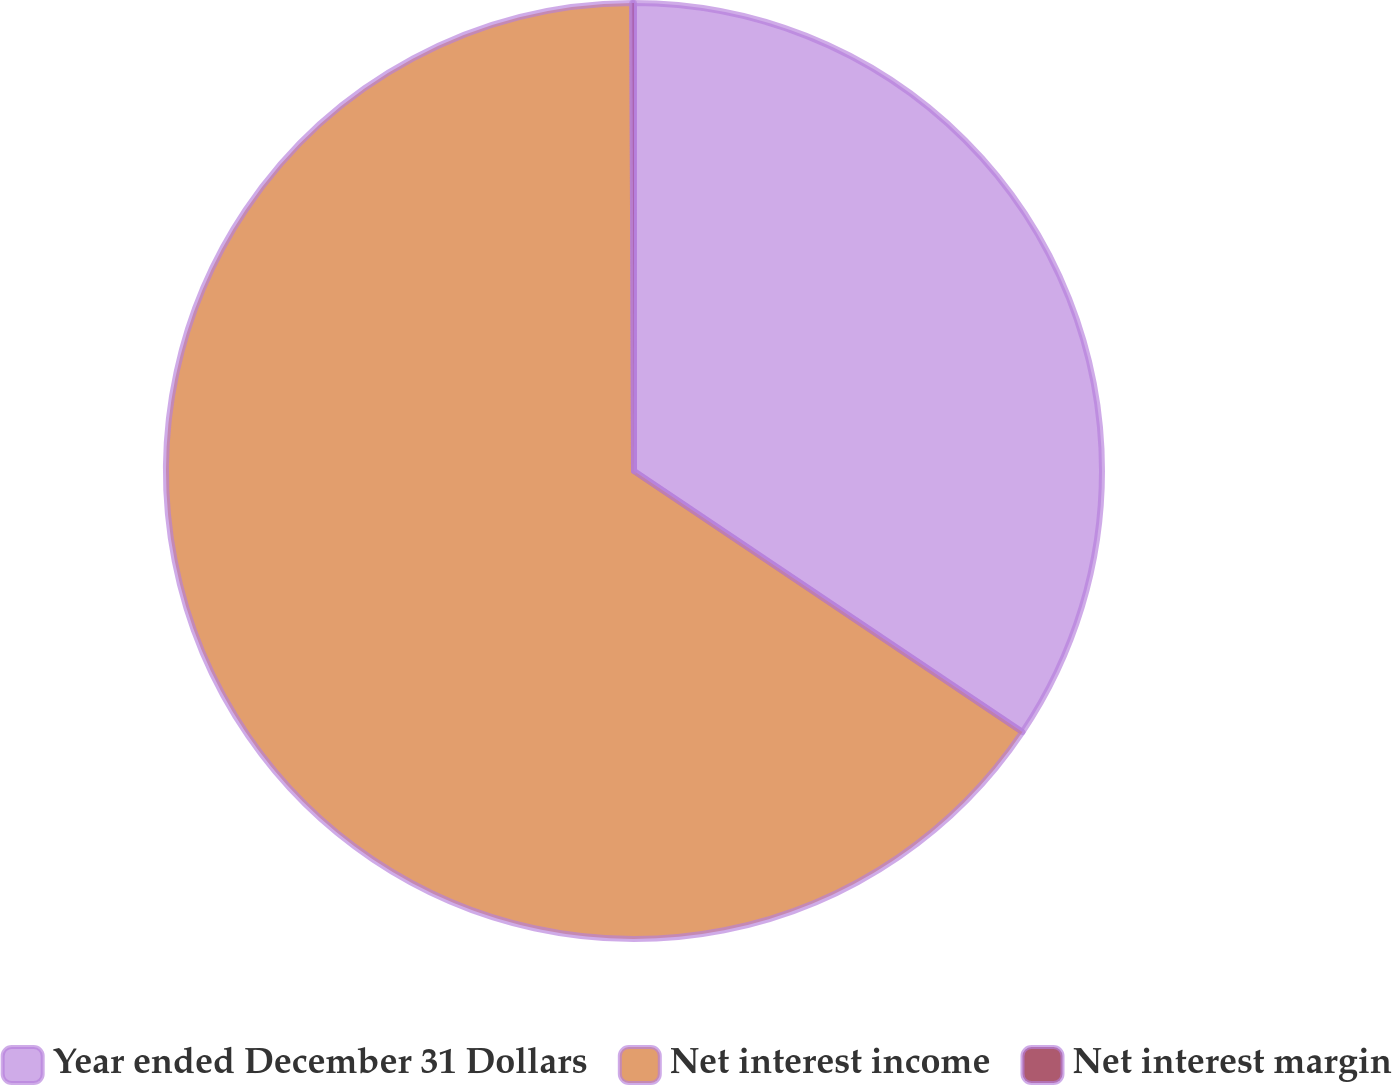<chart> <loc_0><loc_0><loc_500><loc_500><pie_chart><fcel>Year ended December 31 Dollars<fcel>Net interest income<fcel>Net interest margin<nl><fcel>34.42%<fcel>65.53%<fcel>0.06%<nl></chart> 